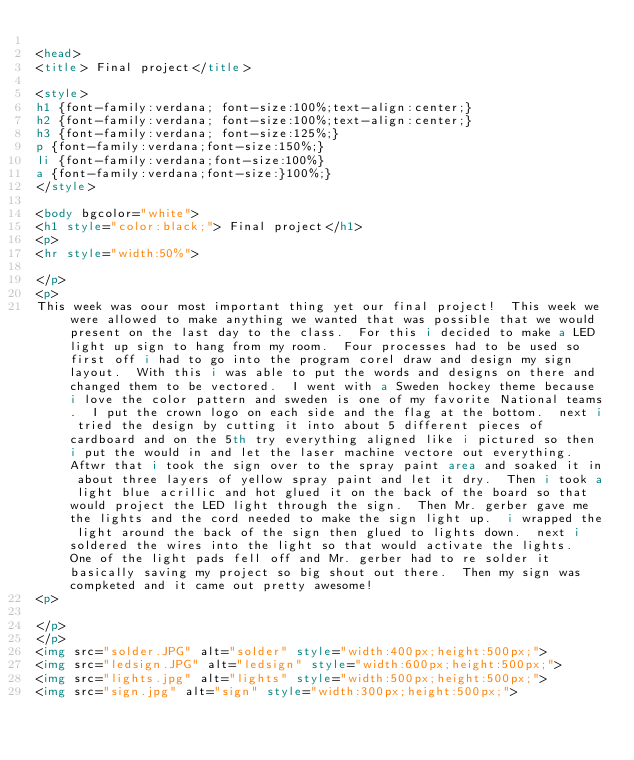<code> <loc_0><loc_0><loc_500><loc_500><_HTML_>
<head>
<title> Final project</title>

<style>
h1 {font-family:verdana; font-size:100%;text-align:center;}
h2 {font-family:verdana; font-size:100%;text-align:center;}
h3 {font-family:verdana; font-size:125%;}
p {font-family:verdana;font-size:150%;}
li {font-family:verdana;font-size:100%}
a {font-family:verdana;font-size:}100%;}
</style>

<body bgcolor="white">
<h1 style="color:black;"> Final project</h1>
<p>
<hr style="width:50%">

</p>
<p>
This week was oour most important thing yet our final project!  This week we were allowed to make anything we wanted that was possible that we would present on the last day to the class.  For this i decided to make a LED light up sign to hang from my room.  Four processes had to be used so first off i had to go into the program corel draw and design my sign layout.  With this i was able to put the words and designs on there and changed them to be vectored.  I went with a Sweden hockey theme because i love the color pattern and sweden is one of my favorite National teams.  I put the crown logo on each side and the flag at the bottom.  next i tried the design by cutting it into about 5 different pieces of cardboard and on the 5th try everything aligned like i pictured so then i put the would in and let the laser machine vectore out everything.  Aftwr that i took the sign over to the spray paint area and soaked it in about three layers of yellow spray paint and let it dry.  Then i took a light blue acrillic and hot glued it on the back of the board so that would project the LED light through the sign.  Then Mr. gerber gave me the lights and the cord needed to make the sign light up.  i wrapped the light around the back of the sign then glued to lights down.  next i soldered the wires into the light so that would activate the lights.  One of the light pads fell off and Mr. gerber had to re solder it basically saving my project so big shout out there.  Then my sign was compketed and it came out pretty awesome!
<p>

</p>
</p>
<img src="solder.JPG" alt="solder" style="width:400px;height:500px;">
<img src="ledsign.JPG" alt="ledsign" style="width:600px;height:500px;">           
<img src="lights.jpg" alt="lights" style="width:500px;height:500px;">
<img src="sign.jpg" alt="sign" style="width:300px;height:500px;">
</code> 